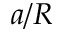Convert formula to latex. <formula><loc_0><loc_0><loc_500><loc_500>a / R</formula> 